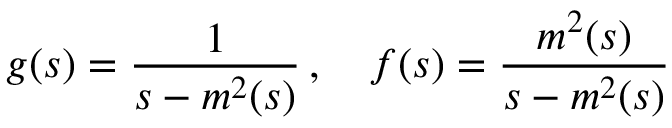Convert formula to latex. <formula><loc_0><loc_0><loc_500><loc_500>g ( s ) = \frac { 1 } { s - m ^ { 2 } ( s ) } \, , \quad f ( s ) = \frac { m ^ { 2 } ( s ) } { s - m ^ { 2 } ( s ) }</formula> 